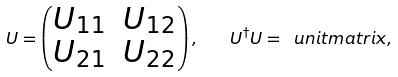<formula> <loc_0><loc_0><loc_500><loc_500>U = \begin{pmatrix} U _ { 1 1 } & U _ { 1 2 } \\ U _ { 2 1 } & U _ { 2 2 } \end{pmatrix} , \quad U ^ { \dagger } U = \ u n i t m a t r i x ,</formula> 